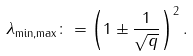Convert formula to latex. <formula><loc_0><loc_0><loc_500><loc_500>\lambda _ { \min , \max } \colon = \left ( 1 \pm \frac { 1 } { \sqrt { q } } \right ) ^ { 2 } .</formula> 